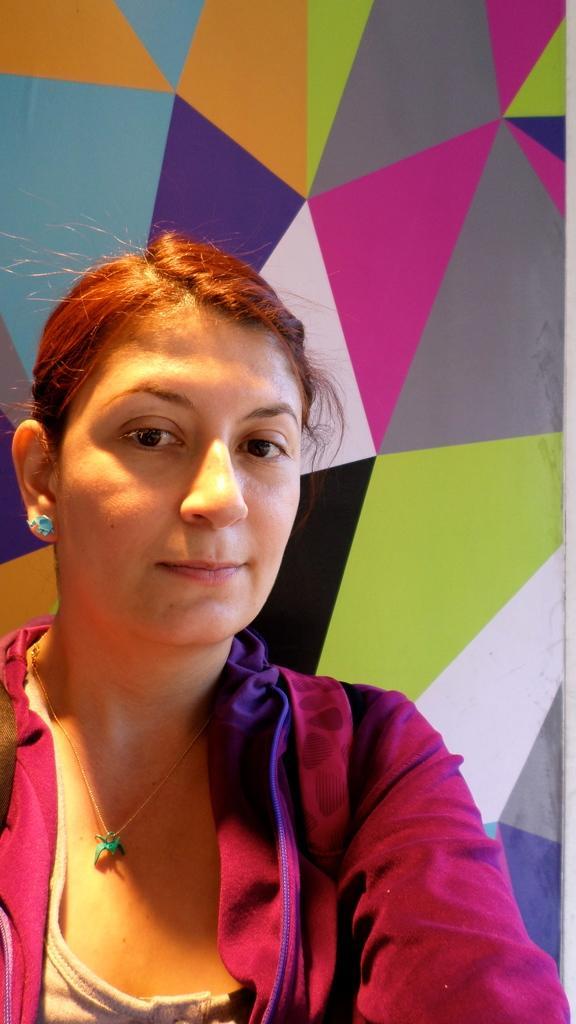Describe this image in one or two sentences. In this picture we can see a woman smiling and in the background we can see wall. 